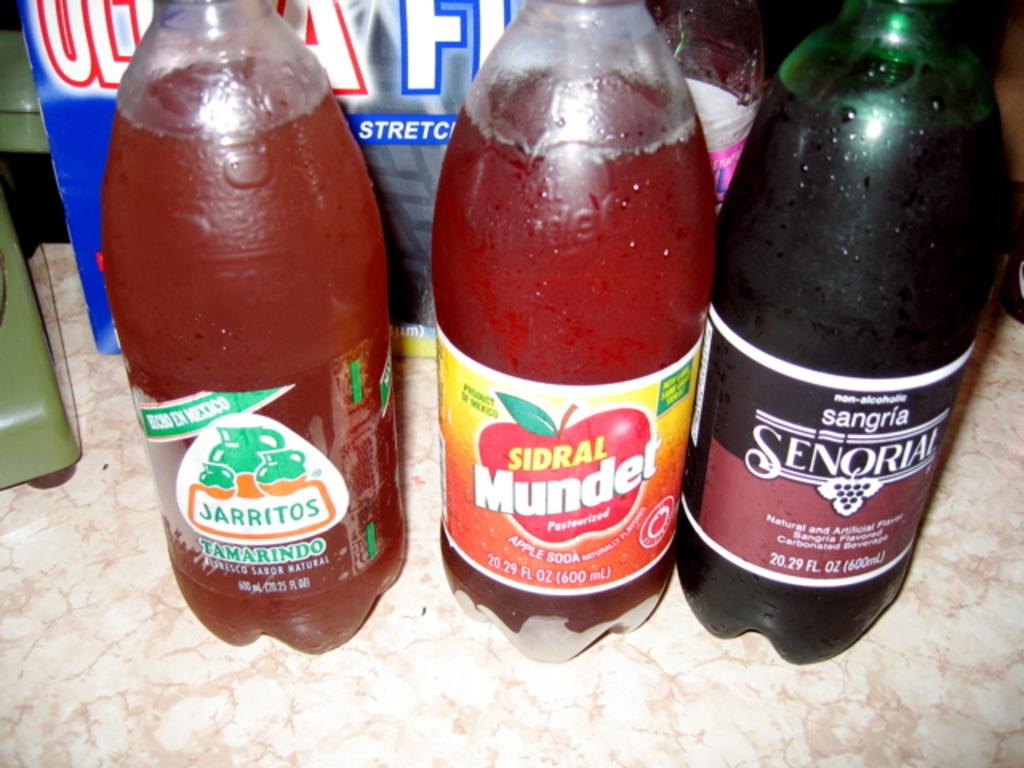<image>
Write a terse but informative summary of the picture. bottles of soda next to each other, one of them being 'tamardindo jarritos' 